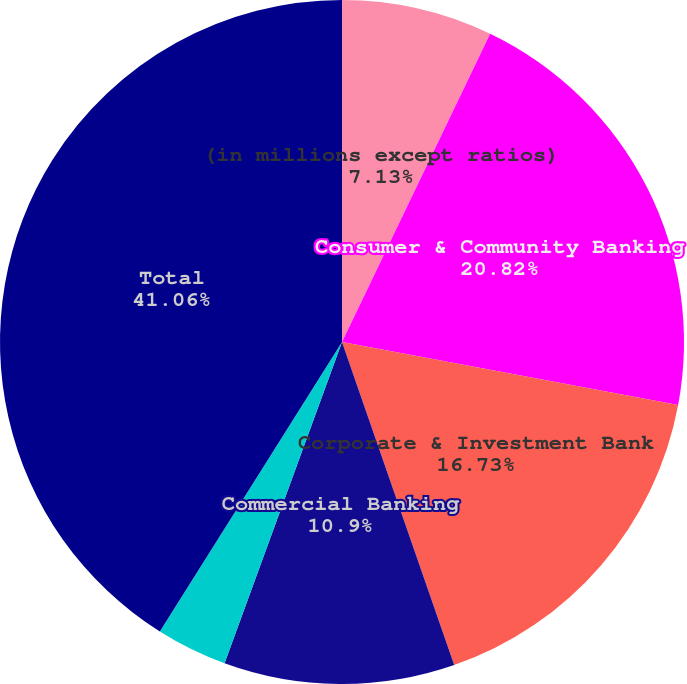Convert chart to OTSL. <chart><loc_0><loc_0><loc_500><loc_500><pie_chart><fcel>(in millions except ratios)<fcel>Consumer & Community Banking<fcel>Corporate & Investment Bank<fcel>Commercial Banking<fcel>Asset Management<fcel>Total<nl><fcel>7.13%<fcel>20.82%<fcel>16.73%<fcel>10.9%<fcel>3.36%<fcel>41.06%<nl></chart> 